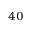<formula> <loc_0><loc_0><loc_500><loc_500>^ { 4 0 }</formula> 